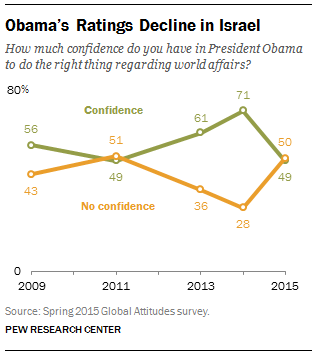Indicate a few pertinent items in this graphic. In 2013, the value of the orange graph was 36. The median value of green graph from 2011 to 2015 was 61. 